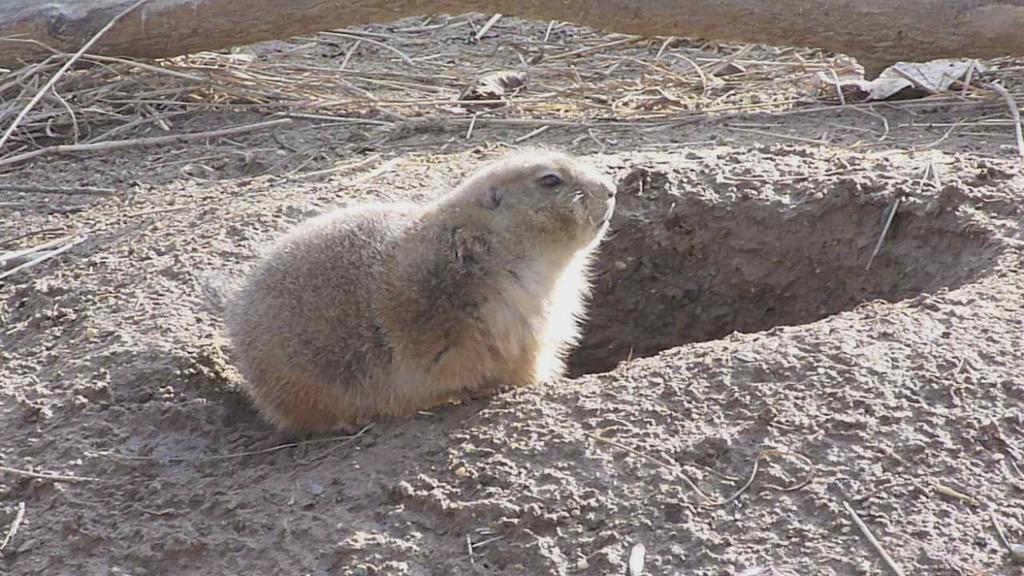Could you give a brief overview of what you see in this image? In this image I can see a cream colour animal and number of sticks on ground. 